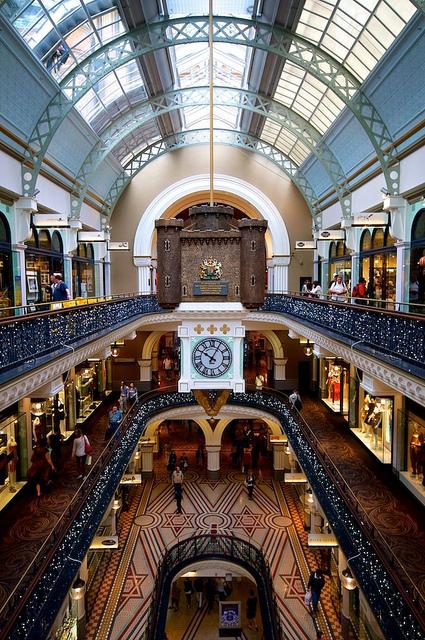Is this photo indoors?
Keep it brief. Yes. How many floors are there in this building?
Be succinct. 4. What time is it?
Short answer required. 10:05. Is this a courthouse?
Short answer required. No. What viewpoint was this picture taken?
Give a very brief answer. Above. 